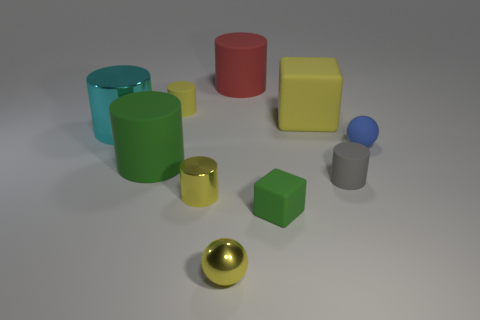Subtract all small rubber cylinders. How many cylinders are left? 4 Subtract 1 cyan cylinders. How many objects are left? 9 Subtract all blocks. How many objects are left? 8 Subtract 1 cubes. How many cubes are left? 1 Subtract all gray balls. Subtract all cyan cylinders. How many balls are left? 2 Subtract all brown spheres. How many blue cylinders are left? 0 Subtract all small yellow cylinders. Subtract all rubber cylinders. How many objects are left? 4 Add 7 small yellow things. How many small yellow things are left? 10 Add 10 tiny red things. How many tiny red things exist? 10 Subtract all cyan cylinders. How many cylinders are left? 5 